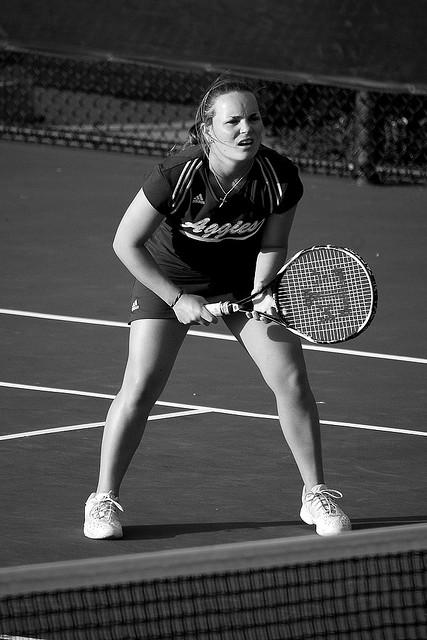What team is this player on?
Give a very brief answer. Aggies. Is this player focused on hitting the ball?
Answer briefly. Yes. Does she have short or long hair?
Quick response, please. Long. 